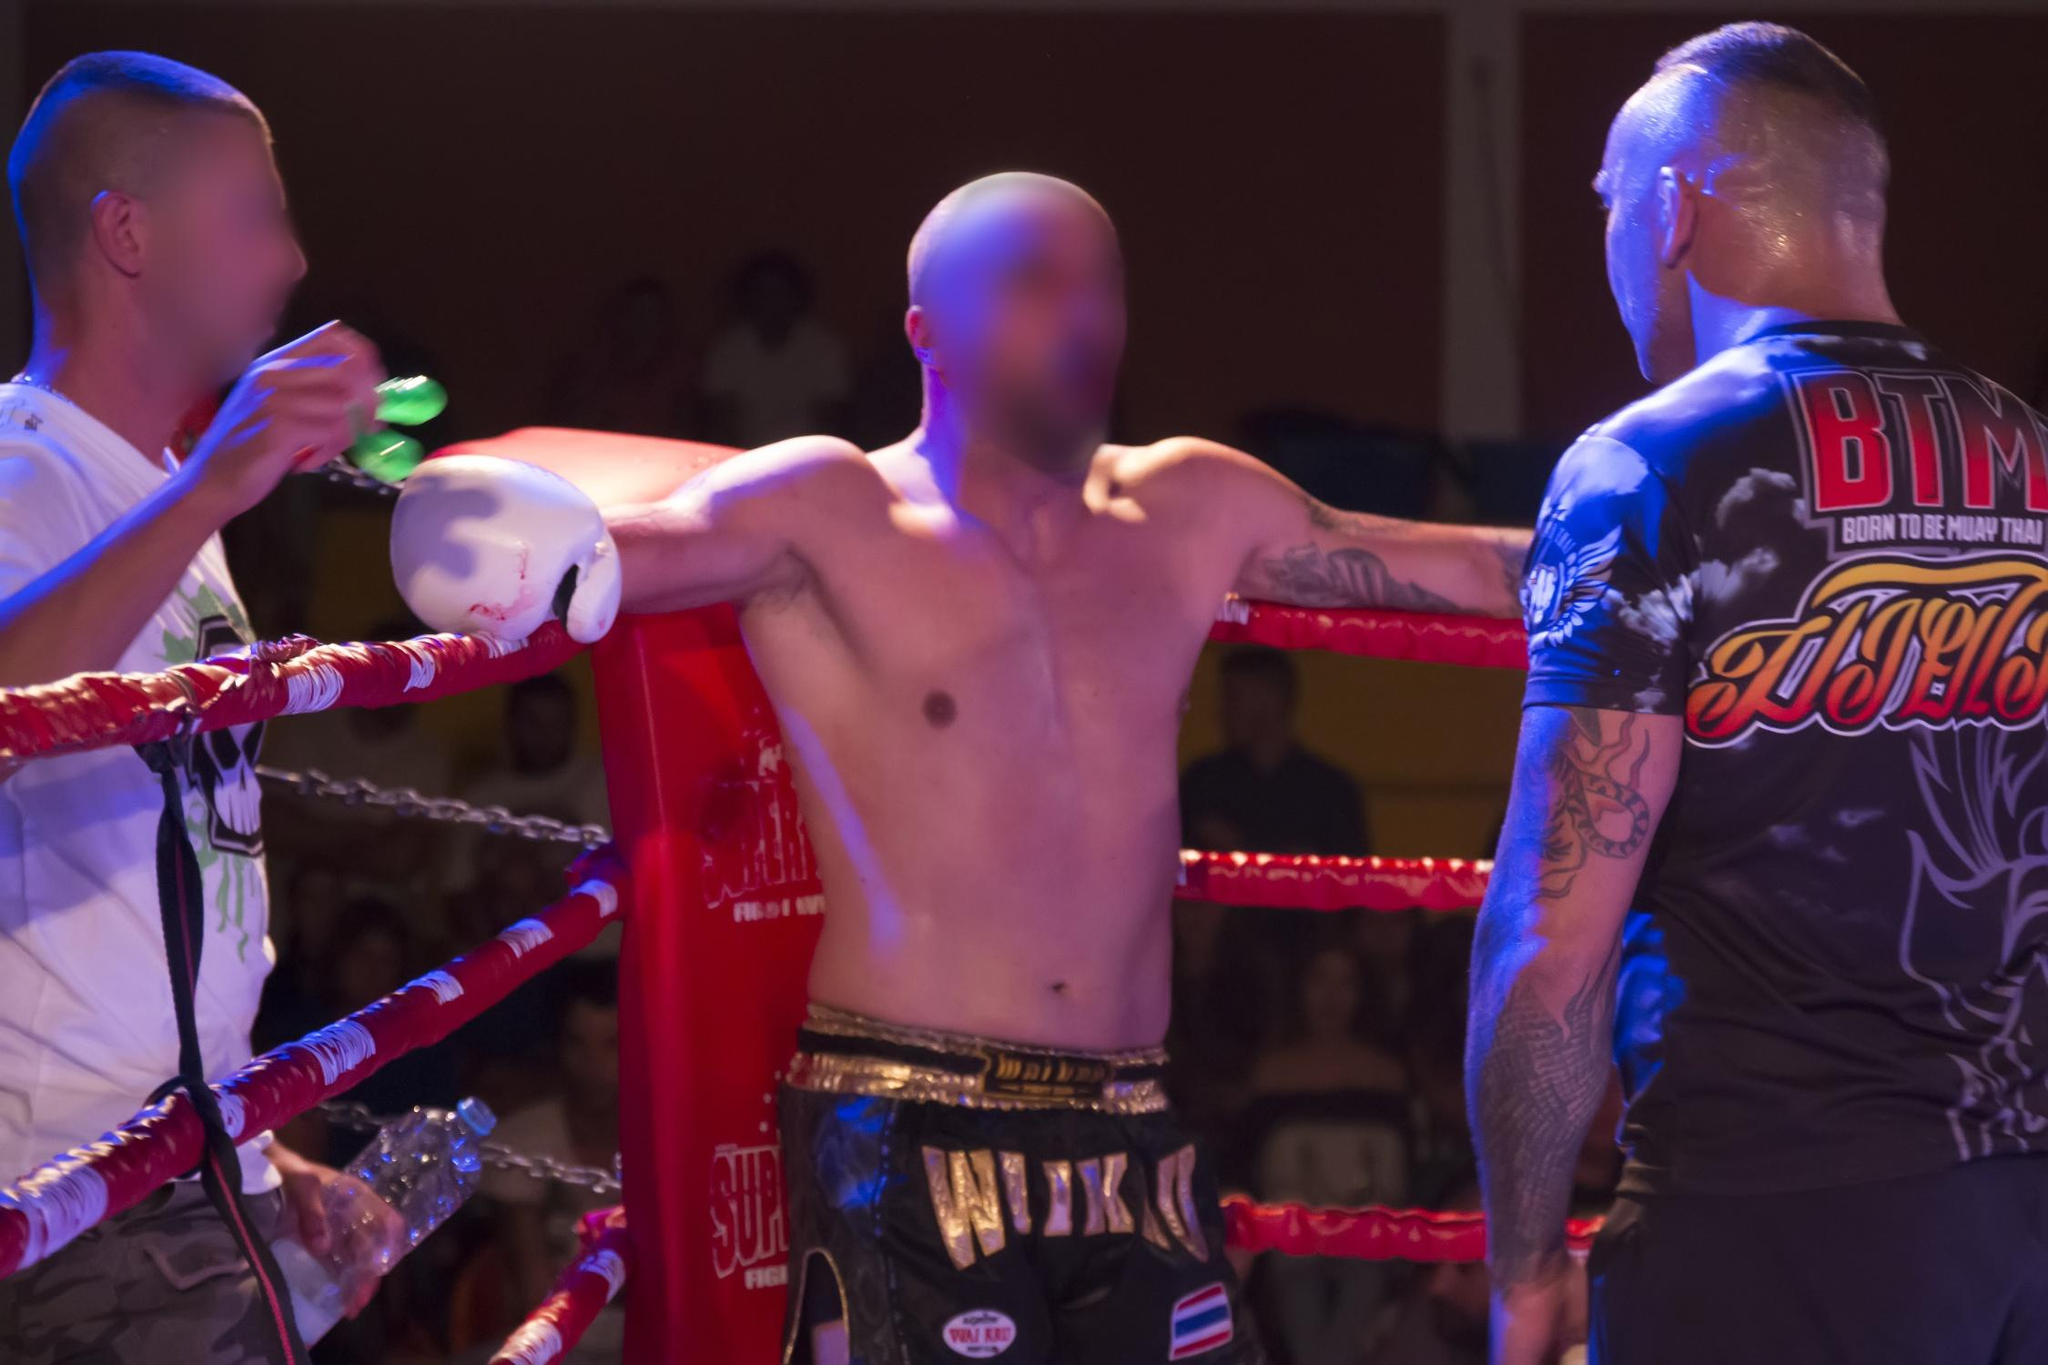What can you tell about the atmosphere in the venue during this boxing match? The atmosphere in the venue appears charged and intense, as evidenced by the audience blurred in the background, which adds a sense of motion and noise typical to such events. The focused lighting on the ring spotlights the central figures, enhancing the drama and immediacy of the contest. This setup suggests a highly engaged crowd, absorbed by the unfolding action, contributing to a palpable sense of anticipation and excitement surrounding the match. 